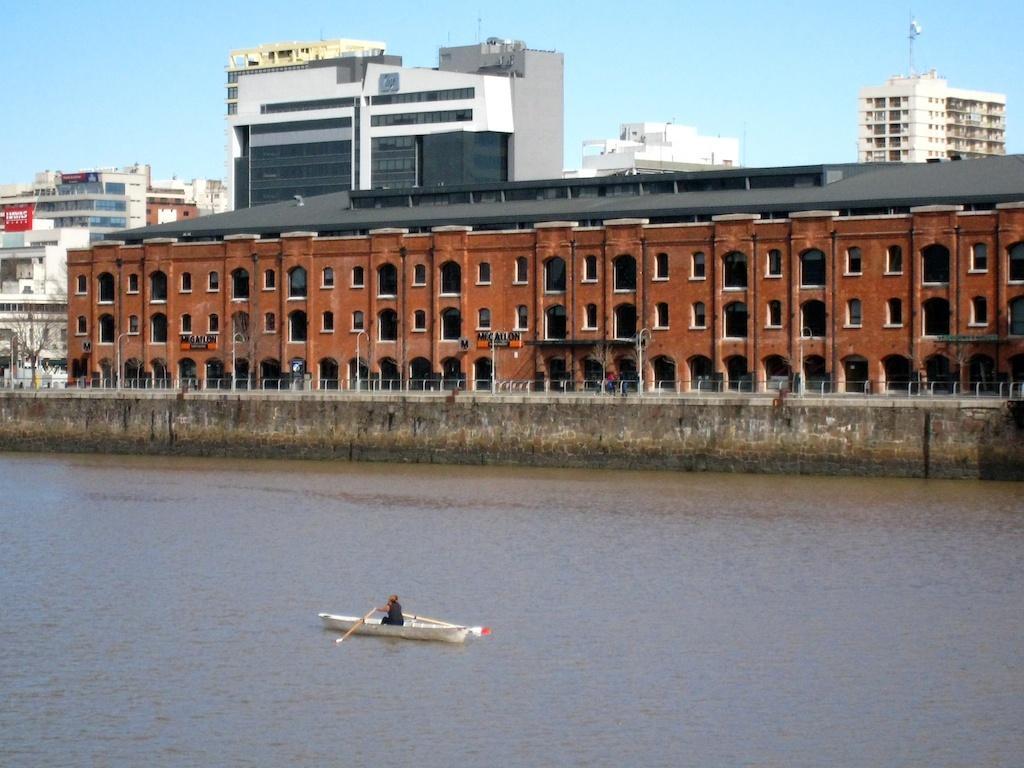Could you give a brief overview of what you see in this image? In this image I can see few buildings, poles, dry tree, sky and one person is holding the paddle and the person is in the boat. The boat is on the water surface. 